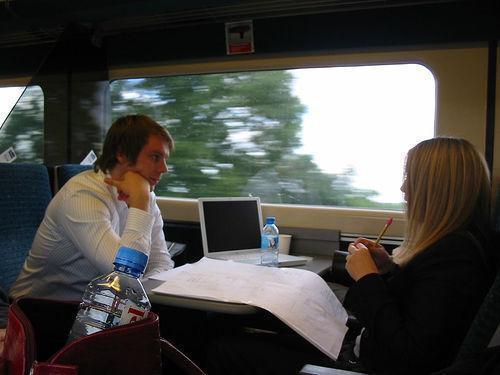How many people are in the picture?
Give a very brief answer. 2. How many water bottles are there?
Give a very brief answer. 2. How many chairs can be seen?
Give a very brief answer. 2. How many people are there?
Give a very brief answer. 2. How many of the bikes are blue?
Give a very brief answer. 0. 